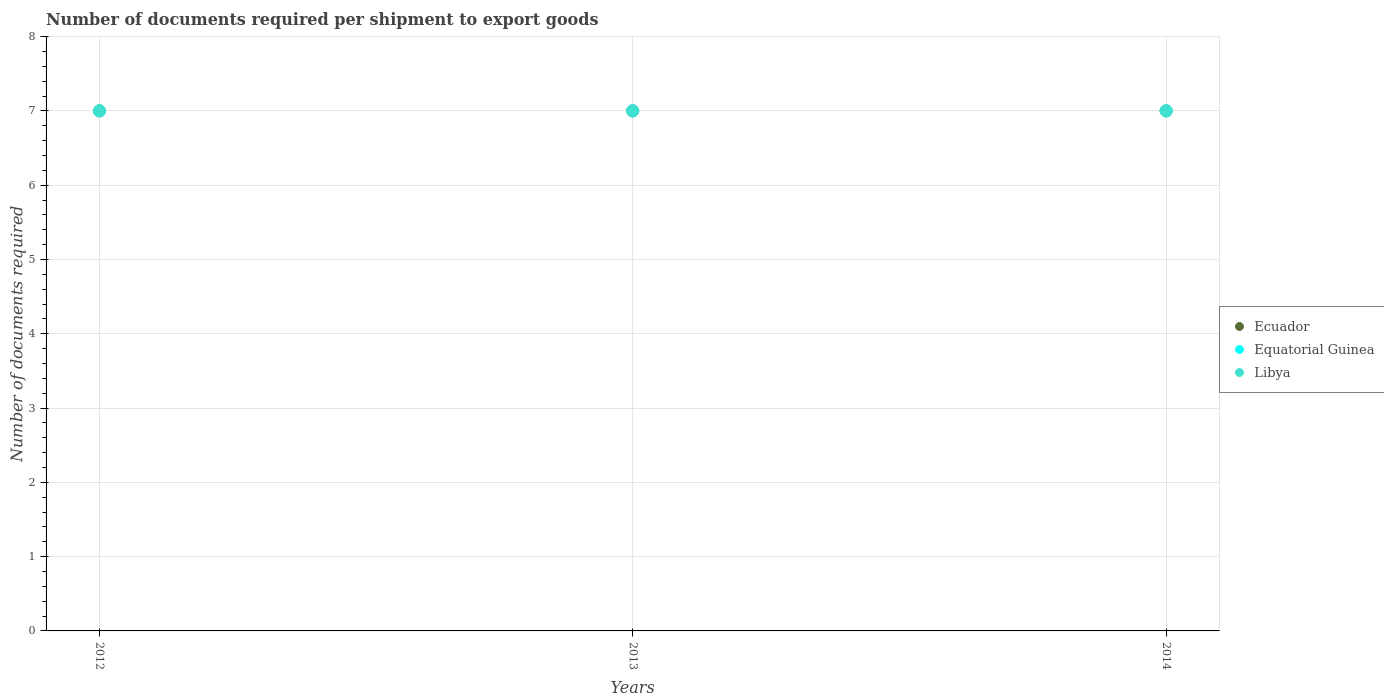How many different coloured dotlines are there?
Your answer should be compact. 3. Is the number of dotlines equal to the number of legend labels?
Give a very brief answer. Yes. What is the number of documents required per shipment to export goods in Equatorial Guinea in 2012?
Offer a terse response. 7. Across all years, what is the maximum number of documents required per shipment to export goods in Libya?
Make the answer very short. 7. What is the total number of documents required per shipment to export goods in Equatorial Guinea in the graph?
Your answer should be very brief. 21. In the year 2014, what is the difference between the number of documents required per shipment to export goods in Ecuador and number of documents required per shipment to export goods in Equatorial Guinea?
Provide a succinct answer. 0. What is the ratio of the number of documents required per shipment to export goods in Libya in 2012 to that in 2014?
Provide a succinct answer. 1. Is the difference between the number of documents required per shipment to export goods in Ecuador in 2013 and 2014 greater than the difference between the number of documents required per shipment to export goods in Equatorial Guinea in 2013 and 2014?
Your response must be concise. No. What is the difference between the highest and the second highest number of documents required per shipment to export goods in Ecuador?
Offer a very short reply. 0. What is the difference between the highest and the lowest number of documents required per shipment to export goods in Ecuador?
Keep it short and to the point. 0. Is the sum of the number of documents required per shipment to export goods in Ecuador in 2012 and 2013 greater than the maximum number of documents required per shipment to export goods in Equatorial Guinea across all years?
Your response must be concise. Yes. Is it the case that in every year, the sum of the number of documents required per shipment to export goods in Libya and number of documents required per shipment to export goods in Ecuador  is greater than the number of documents required per shipment to export goods in Equatorial Guinea?
Ensure brevity in your answer.  Yes. Does the number of documents required per shipment to export goods in Equatorial Guinea monotonically increase over the years?
Provide a succinct answer. No. Is the number of documents required per shipment to export goods in Equatorial Guinea strictly less than the number of documents required per shipment to export goods in Libya over the years?
Make the answer very short. No. How many years are there in the graph?
Ensure brevity in your answer.  3. Where does the legend appear in the graph?
Your answer should be compact. Center right. How many legend labels are there?
Your answer should be very brief. 3. What is the title of the graph?
Ensure brevity in your answer.  Number of documents required per shipment to export goods. What is the label or title of the Y-axis?
Ensure brevity in your answer.  Number of documents required. What is the Number of documents required in Equatorial Guinea in 2013?
Ensure brevity in your answer.  7. What is the Number of documents required of Libya in 2014?
Your response must be concise. 7. Across all years, what is the maximum Number of documents required of Equatorial Guinea?
Ensure brevity in your answer.  7. Across all years, what is the maximum Number of documents required of Libya?
Your answer should be compact. 7. What is the difference between the Number of documents required in Equatorial Guinea in 2012 and that in 2013?
Give a very brief answer. 0. What is the difference between the Number of documents required of Libya in 2012 and that in 2013?
Ensure brevity in your answer.  0. What is the difference between the Number of documents required of Ecuador in 2012 and that in 2014?
Offer a very short reply. 0. What is the difference between the Number of documents required of Equatorial Guinea in 2012 and that in 2014?
Give a very brief answer. 0. What is the difference between the Number of documents required in Libya in 2012 and that in 2014?
Offer a terse response. 0. What is the difference between the Number of documents required in Equatorial Guinea in 2013 and that in 2014?
Keep it short and to the point. 0. What is the difference between the Number of documents required in Libya in 2013 and that in 2014?
Provide a succinct answer. 0. What is the difference between the Number of documents required in Ecuador in 2013 and the Number of documents required in Equatorial Guinea in 2014?
Offer a very short reply. 0. In the year 2012, what is the difference between the Number of documents required of Equatorial Guinea and Number of documents required of Libya?
Your answer should be compact. 0. In the year 2013, what is the difference between the Number of documents required of Ecuador and Number of documents required of Equatorial Guinea?
Give a very brief answer. 0. In the year 2013, what is the difference between the Number of documents required in Equatorial Guinea and Number of documents required in Libya?
Make the answer very short. 0. What is the ratio of the Number of documents required of Equatorial Guinea in 2012 to that in 2013?
Give a very brief answer. 1. What is the ratio of the Number of documents required of Ecuador in 2012 to that in 2014?
Offer a very short reply. 1. What is the ratio of the Number of documents required in Ecuador in 2013 to that in 2014?
Provide a short and direct response. 1. What is the ratio of the Number of documents required in Equatorial Guinea in 2013 to that in 2014?
Ensure brevity in your answer.  1. What is the ratio of the Number of documents required of Libya in 2013 to that in 2014?
Provide a succinct answer. 1. What is the difference between the highest and the second highest Number of documents required in Equatorial Guinea?
Keep it short and to the point. 0. What is the difference between the highest and the lowest Number of documents required in Ecuador?
Provide a succinct answer. 0. 